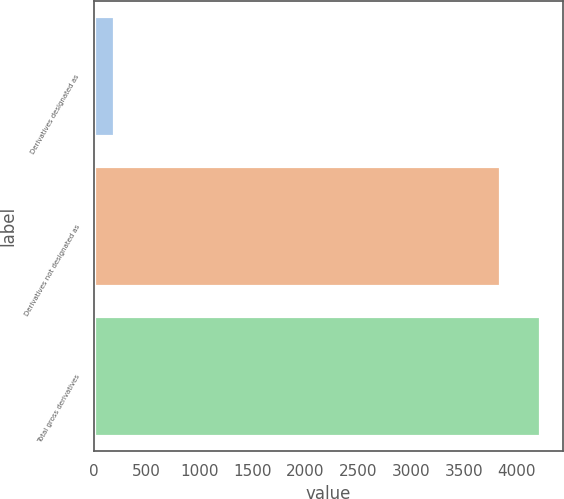<chart> <loc_0><loc_0><loc_500><loc_500><bar_chart><fcel>Derivatives designated as<fcel>Derivatives not designated as<fcel>Total gross derivatives<nl><fcel>186<fcel>3841<fcel>4225.1<nl></chart> 